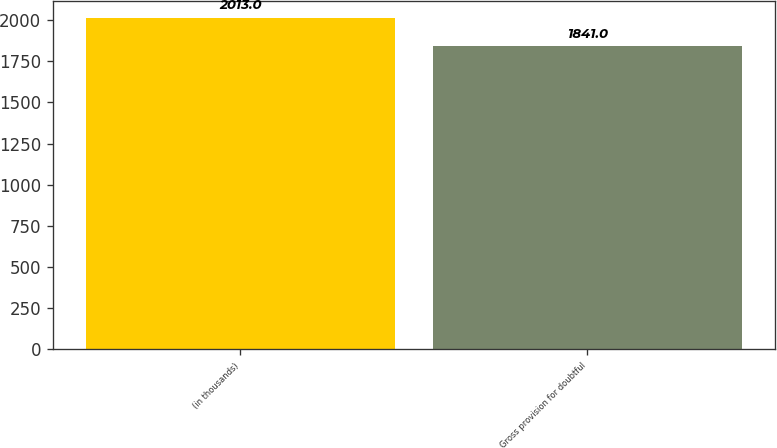Convert chart. <chart><loc_0><loc_0><loc_500><loc_500><bar_chart><fcel>(in thousands)<fcel>Gross provision for doubtful<nl><fcel>2013<fcel>1841<nl></chart> 